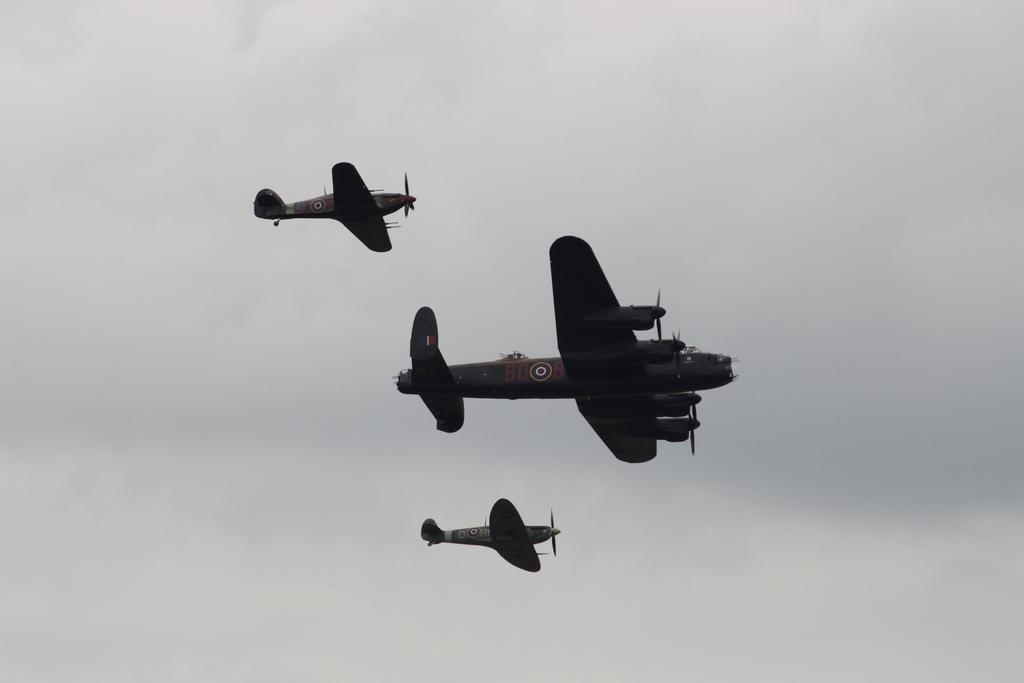Please provide a concise description of this image. In the center of the picture there are aircrafts. The sky is cloudy. 